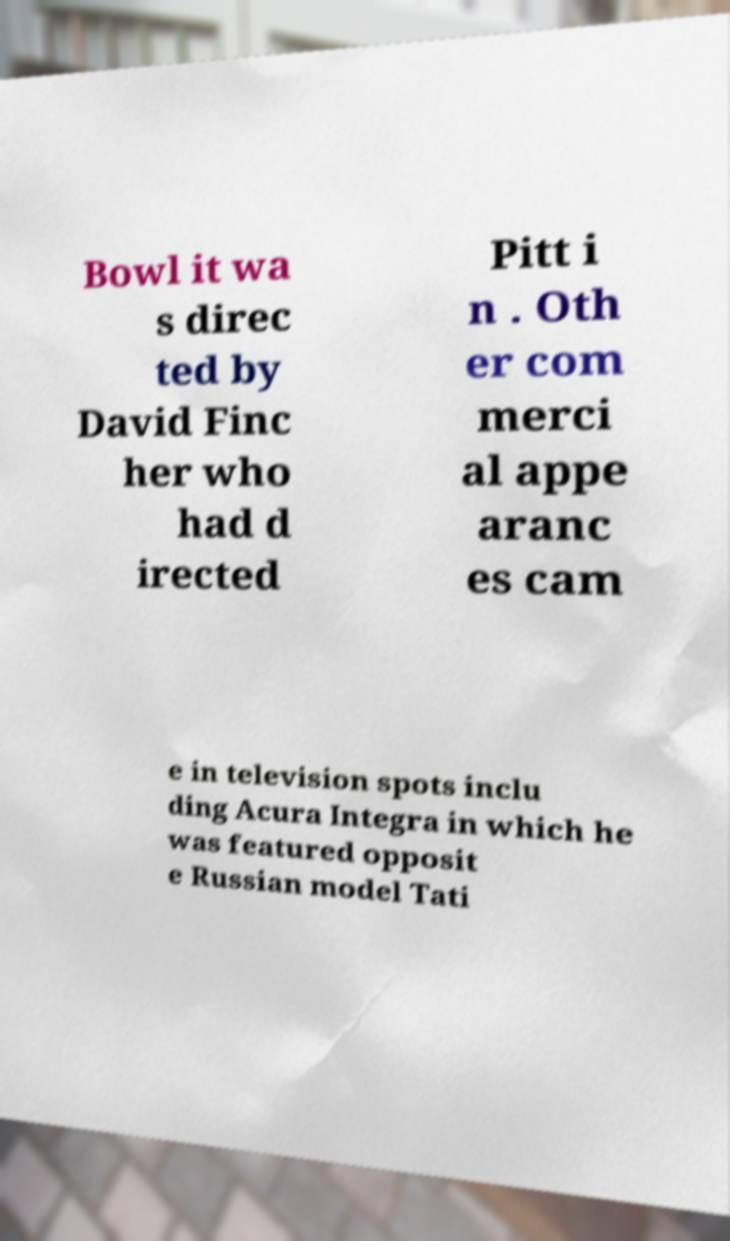Please read and relay the text visible in this image. What does it say? Bowl it wa s direc ted by David Finc her who had d irected Pitt i n . Oth er com merci al appe aranc es cam e in television spots inclu ding Acura Integra in which he was featured opposit e Russian model Tati 